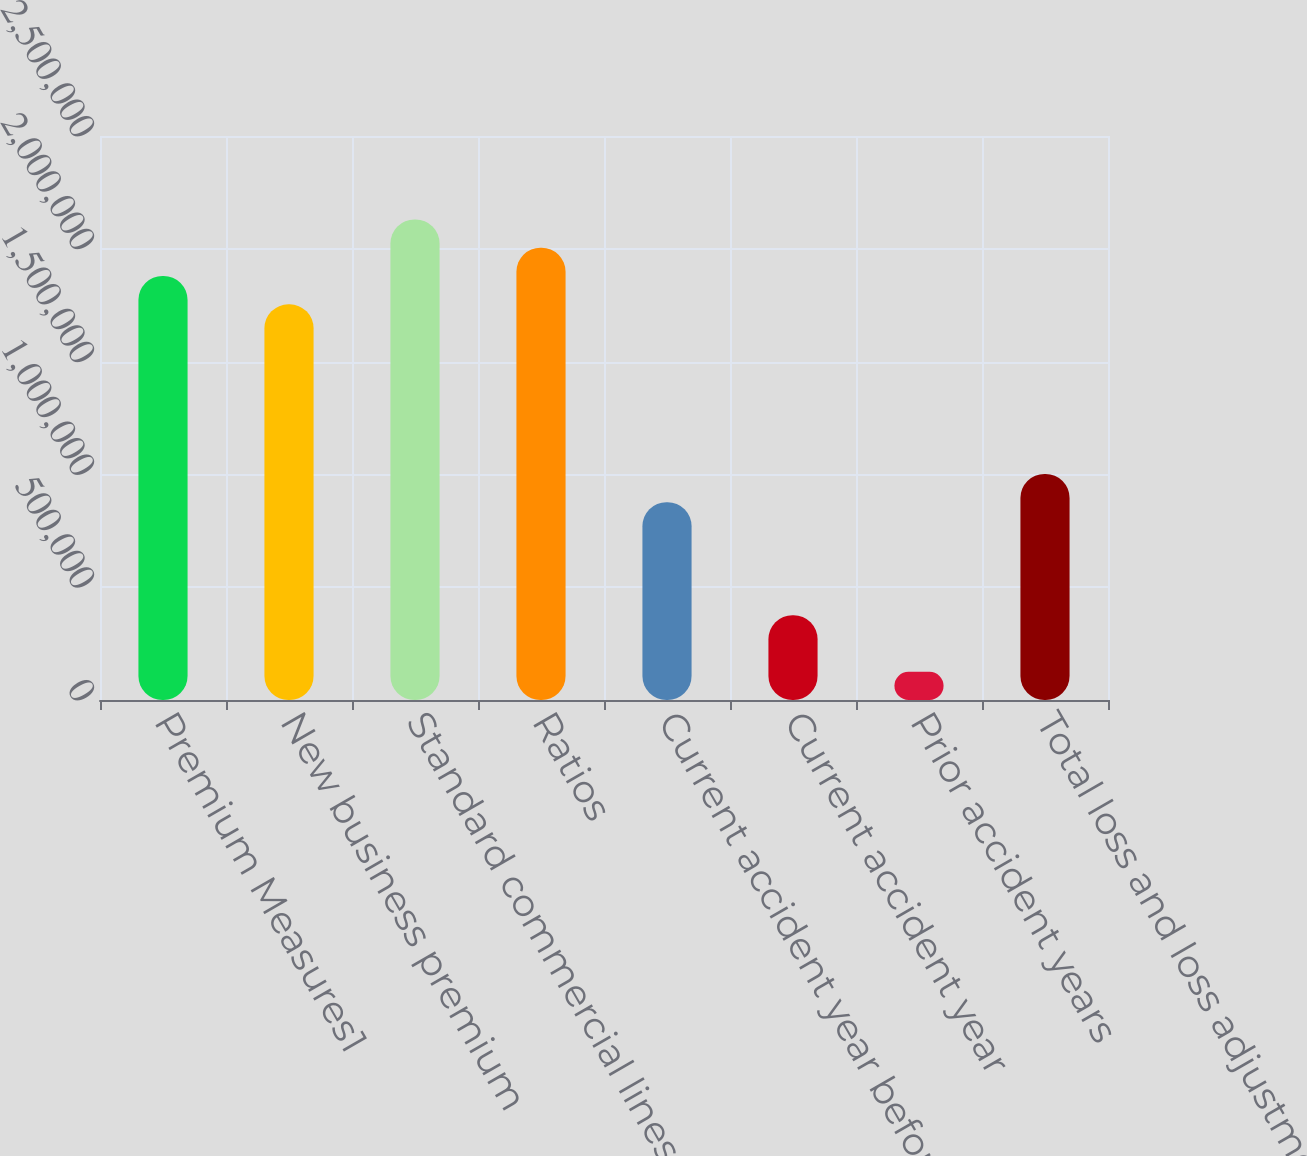Convert chart. <chart><loc_0><loc_0><loc_500><loc_500><bar_chart><fcel>Premium Measures1<fcel>New business premium<fcel>Standard commercial lines<fcel>Ratios<fcel>Current accident year before<fcel>Current accident year<fcel>Prior accident years<fcel>Total loss and loss adjustment<nl><fcel>1.87923e+06<fcel>1.75395e+06<fcel>2.12979e+06<fcel>2.00451e+06<fcel>876974<fcel>375846<fcel>125282<fcel>1.00226e+06<nl></chart> 